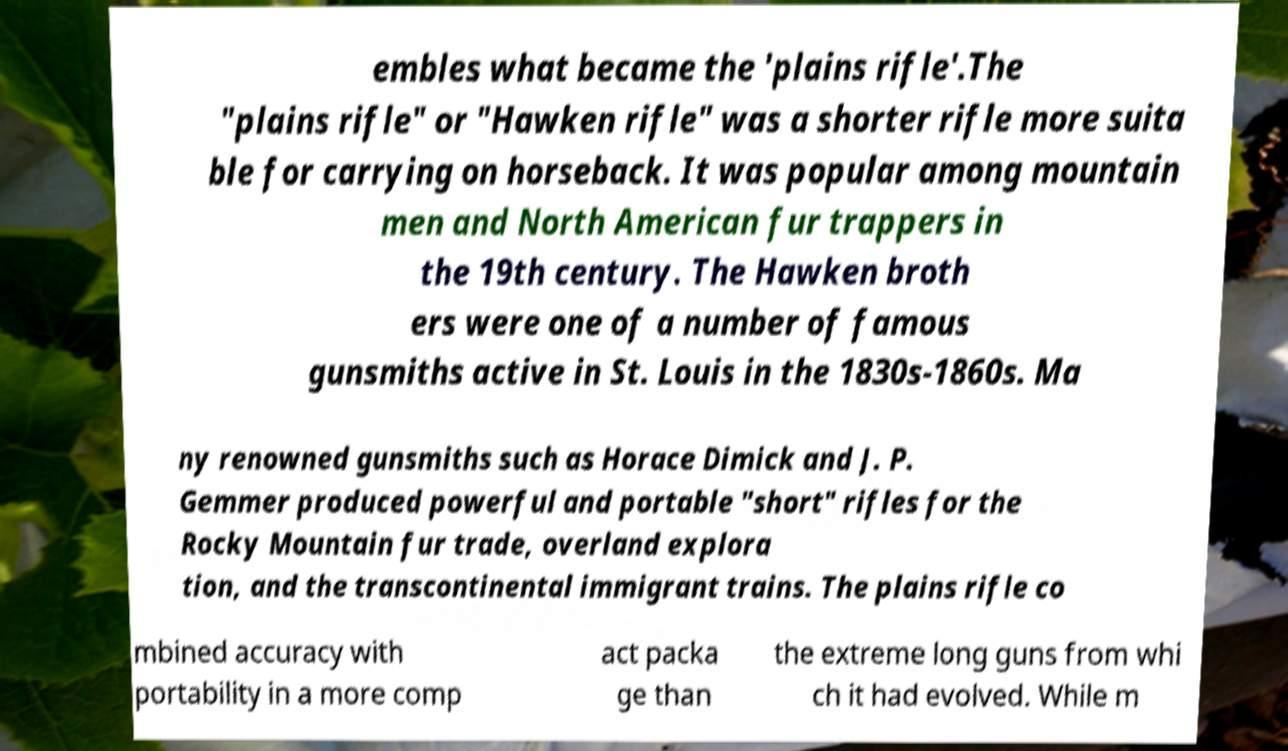Please identify and transcribe the text found in this image. embles what became the 'plains rifle'.The "plains rifle" or "Hawken rifle" was a shorter rifle more suita ble for carrying on horseback. It was popular among mountain men and North American fur trappers in the 19th century. The Hawken broth ers were one of a number of famous gunsmiths active in St. Louis in the 1830s-1860s. Ma ny renowned gunsmiths such as Horace Dimick and J. P. Gemmer produced powerful and portable "short" rifles for the Rocky Mountain fur trade, overland explora tion, and the transcontinental immigrant trains. The plains rifle co mbined accuracy with portability in a more comp act packa ge than the extreme long guns from whi ch it had evolved. While m 